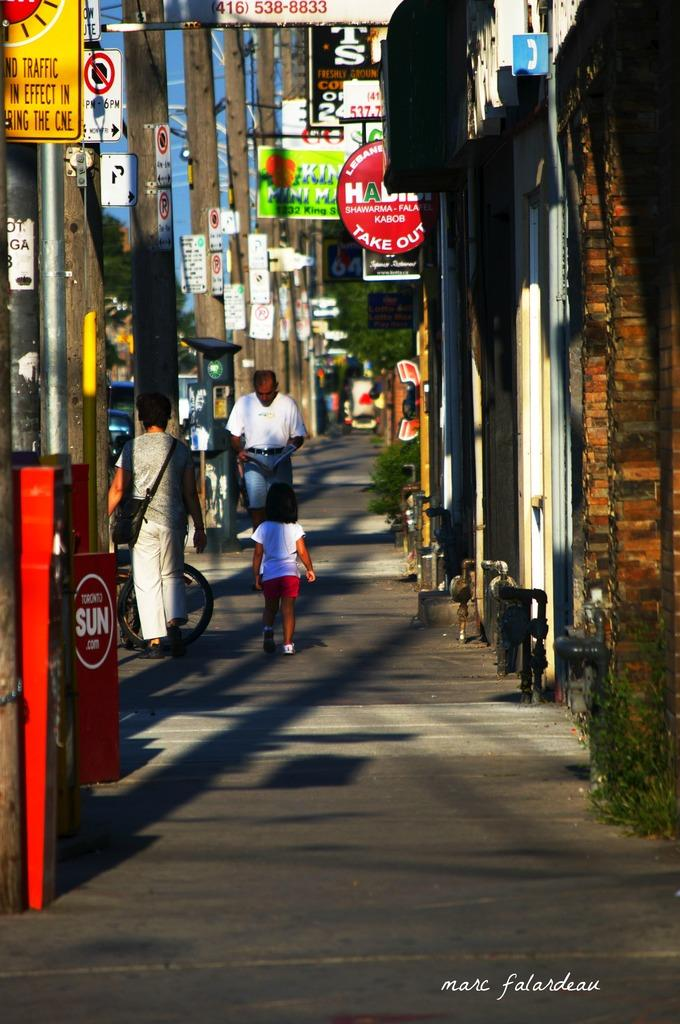<image>
Create a compact narrative representing the image presented. People walking on a street in front of a building that says "Take Out". 